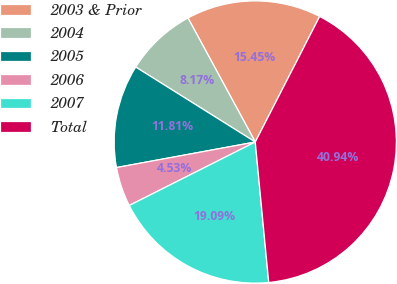<chart> <loc_0><loc_0><loc_500><loc_500><pie_chart><fcel>2003 & Prior<fcel>2004<fcel>2005<fcel>2006<fcel>2007<fcel>Total<nl><fcel>15.45%<fcel>8.17%<fcel>11.81%<fcel>4.53%<fcel>19.09%<fcel>40.93%<nl></chart> 